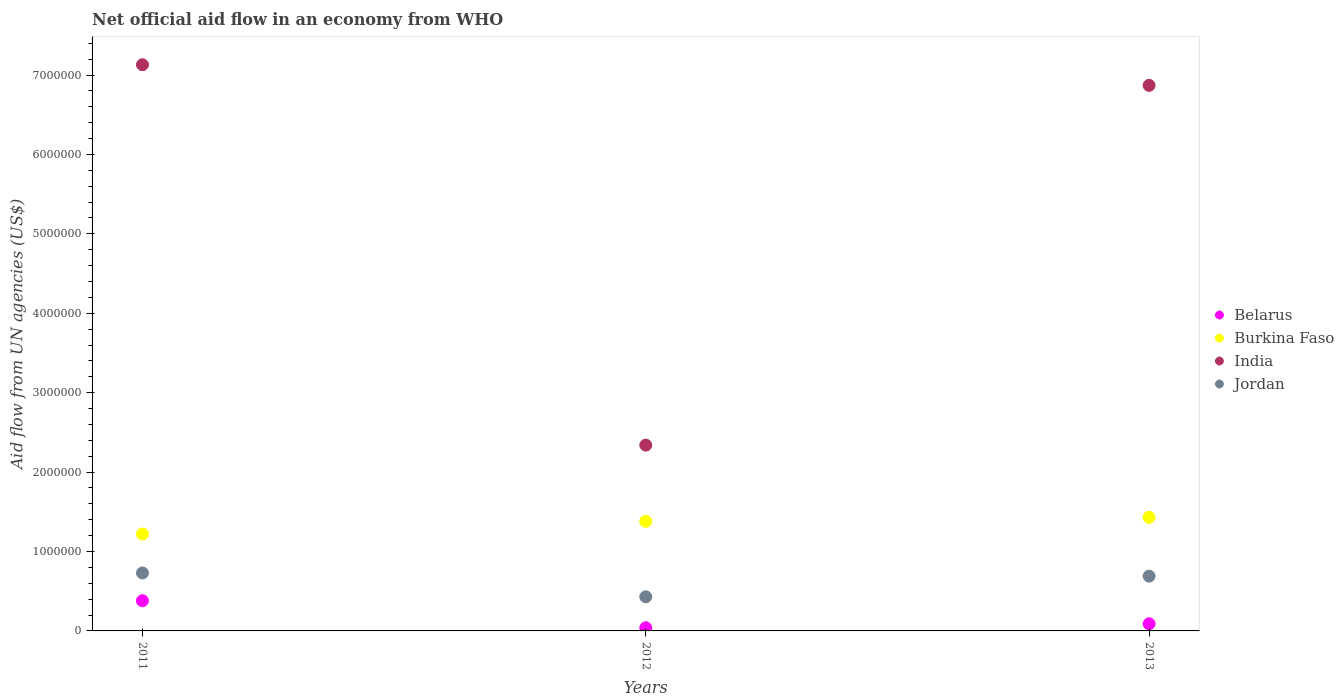What is the net official aid flow in Jordan in 2013?
Offer a terse response. 6.90e+05. Across all years, what is the maximum net official aid flow in Jordan?
Your response must be concise. 7.30e+05. What is the total net official aid flow in Belarus in the graph?
Your answer should be very brief. 5.10e+05. What is the difference between the net official aid flow in Jordan in 2011 and that in 2013?
Offer a very short reply. 4.00e+04. What is the difference between the net official aid flow in Jordan in 2011 and the net official aid flow in Belarus in 2013?
Keep it short and to the point. 6.40e+05. What is the average net official aid flow in India per year?
Offer a terse response. 5.45e+06. In the year 2011, what is the difference between the net official aid flow in Jordan and net official aid flow in Burkina Faso?
Offer a very short reply. -4.90e+05. In how many years, is the net official aid flow in Jordan greater than 200000 US$?
Make the answer very short. 3. What is the ratio of the net official aid flow in India in 2011 to that in 2012?
Your answer should be compact. 3.05. What is the difference between the highest and the lowest net official aid flow in Belarus?
Keep it short and to the point. 3.40e+05. Is it the case that in every year, the sum of the net official aid flow in Jordan and net official aid flow in Burkina Faso  is greater than the sum of net official aid flow in Belarus and net official aid flow in India?
Offer a very short reply. No. Is it the case that in every year, the sum of the net official aid flow in Belarus and net official aid flow in Jordan  is greater than the net official aid flow in Burkina Faso?
Keep it short and to the point. No. Does the net official aid flow in India monotonically increase over the years?
Offer a terse response. No. Is the net official aid flow in India strictly greater than the net official aid flow in Belarus over the years?
Provide a short and direct response. Yes. How many years are there in the graph?
Offer a terse response. 3. What is the difference between two consecutive major ticks on the Y-axis?
Give a very brief answer. 1.00e+06. Are the values on the major ticks of Y-axis written in scientific E-notation?
Make the answer very short. No. What is the title of the graph?
Offer a terse response. Net official aid flow in an economy from WHO. What is the label or title of the X-axis?
Provide a short and direct response. Years. What is the label or title of the Y-axis?
Your response must be concise. Aid flow from UN agencies (US$). What is the Aid flow from UN agencies (US$) of Belarus in 2011?
Your answer should be compact. 3.80e+05. What is the Aid flow from UN agencies (US$) in Burkina Faso in 2011?
Offer a very short reply. 1.22e+06. What is the Aid flow from UN agencies (US$) in India in 2011?
Provide a succinct answer. 7.13e+06. What is the Aid flow from UN agencies (US$) in Jordan in 2011?
Offer a very short reply. 7.30e+05. What is the Aid flow from UN agencies (US$) in Burkina Faso in 2012?
Ensure brevity in your answer.  1.38e+06. What is the Aid flow from UN agencies (US$) in India in 2012?
Your answer should be compact. 2.34e+06. What is the Aid flow from UN agencies (US$) in Belarus in 2013?
Offer a very short reply. 9.00e+04. What is the Aid flow from UN agencies (US$) in Burkina Faso in 2013?
Make the answer very short. 1.43e+06. What is the Aid flow from UN agencies (US$) of India in 2013?
Offer a terse response. 6.87e+06. What is the Aid flow from UN agencies (US$) of Jordan in 2013?
Your answer should be compact. 6.90e+05. Across all years, what is the maximum Aid flow from UN agencies (US$) of Burkina Faso?
Your answer should be very brief. 1.43e+06. Across all years, what is the maximum Aid flow from UN agencies (US$) in India?
Your answer should be compact. 7.13e+06. Across all years, what is the maximum Aid flow from UN agencies (US$) of Jordan?
Your answer should be very brief. 7.30e+05. Across all years, what is the minimum Aid flow from UN agencies (US$) of Burkina Faso?
Your answer should be very brief. 1.22e+06. Across all years, what is the minimum Aid flow from UN agencies (US$) in India?
Your response must be concise. 2.34e+06. Across all years, what is the minimum Aid flow from UN agencies (US$) in Jordan?
Provide a succinct answer. 4.30e+05. What is the total Aid flow from UN agencies (US$) of Belarus in the graph?
Provide a succinct answer. 5.10e+05. What is the total Aid flow from UN agencies (US$) of Burkina Faso in the graph?
Offer a terse response. 4.03e+06. What is the total Aid flow from UN agencies (US$) of India in the graph?
Provide a short and direct response. 1.63e+07. What is the total Aid flow from UN agencies (US$) of Jordan in the graph?
Offer a very short reply. 1.85e+06. What is the difference between the Aid flow from UN agencies (US$) in Belarus in 2011 and that in 2012?
Offer a very short reply. 3.40e+05. What is the difference between the Aid flow from UN agencies (US$) in Burkina Faso in 2011 and that in 2012?
Make the answer very short. -1.60e+05. What is the difference between the Aid flow from UN agencies (US$) of India in 2011 and that in 2012?
Make the answer very short. 4.79e+06. What is the difference between the Aid flow from UN agencies (US$) of Jordan in 2011 and that in 2012?
Keep it short and to the point. 3.00e+05. What is the difference between the Aid flow from UN agencies (US$) in Belarus in 2011 and that in 2013?
Ensure brevity in your answer.  2.90e+05. What is the difference between the Aid flow from UN agencies (US$) of Burkina Faso in 2011 and that in 2013?
Ensure brevity in your answer.  -2.10e+05. What is the difference between the Aid flow from UN agencies (US$) in India in 2011 and that in 2013?
Give a very brief answer. 2.60e+05. What is the difference between the Aid flow from UN agencies (US$) of Jordan in 2011 and that in 2013?
Ensure brevity in your answer.  4.00e+04. What is the difference between the Aid flow from UN agencies (US$) in Belarus in 2012 and that in 2013?
Offer a very short reply. -5.00e+04. What is the difference between the Aid flow from UN agencies (US$) of Burkina Faso in 2012 and that in 2013?
Provide a succinct answer. -5.00e+04. What is the difference between the Aid flow from UN agencies (US$) in India in 2012 and that in 2013?
Offer a terse response. -4.53e+06. What is the difference between the Aid flow from UN agencies (US$) in Jordan in 2012 and that in 2013?
Provide a succinct answer. -2.60e+05. What is the difference between the Aid flow from UN agencies (US$) in Belarus in 2011 and the Aid flow from UN agencies (US$) in India in 2012?
Give a very brief answer. -1.96e+06. What is the difference between the Aid flow from UN agencies (US$) of Burkina Faso in 2011 and the Aid flow from UN agencies (US$) of India in 2012?
Keep it short and to the point. -1.12e+06. What is the difference between the Aid flow from UN agencies (US$) of Burkina Faso in 2011 and the Aid flow from UN agencies (US$) of Jordan in 2012?
Provide a succinct answer. 7.90e+05. What is the difference between the Aid flow from UN agencies (US$) in India in 2011 and the Aid flow from UN agencies (US$) in Jordan in 2012?
Your answer should be compact. 6.70e+06. What is the difference between the Aid flow from UN agencies (US$) of Belarus in 2011 and the Aid flow from UN agencies (US$) of Burkina Faso in 2013?
Keep it short and to the point. -1.05e+06. What is the difference between the Aid flow from UN agencies (US$) of Belarus in 2011 and the Aid flow from UN agencies (US$) of India in 2013?
Your answer should be compact. -6.49e+06. What is the difference between the Aid flow from UN agencies (US$) in Belarus in 2011 and the Aid flow from UN agencies (US$) in Jordan in 2013?
Offer a terse response. -3.10e+05. What is the difference between the Aid flow from UN agencies (US$) of Burkina Faso in 2011 and the Aid flow from UN agencies (US$) of India in 2013?
Give a very brief answer. -5.65e+06. What is the difference between the Aid flow from UN agencies (US$) of Burkina Faso in 2011 and the Aid flow from UN agencies (US$) of Jordan in 2013?
Keep it short and to the point. 5.30e+05. What is the difference between the Aid flow from UN agencies (US$) in India in 2011 and the Aid flow from UN agencies (US$) in Jordan in 2013?
Provide a succinct answer. 6.44e+06. What is the difference between the Aid flow from UN agencies (US$) of Belarus in 2012 and the Aid flow from UN agencies (US$) of Burkina Faso in 2013?
Provide a short and direct response. -1.39e+06. What is the difference between the Aid flow from UN agencies (US$) of Belarus in 2012 and the Aid flow from UN agencies (US$) of India in 2013?
Make the answer very short. -6.83e+06. What is the difference between the Aid flow from UN agencies (US$) of Belarus in 2012 and the Aid flow from UN agencies (US$) of Jordan in 2013?
Offer a very short reply. -6.50e+05. What is the difference between the Aid flow from UN agencies (US$) in Burkina Faso in 2012 and the Aid flow from UN agencies (US$) in India in 2013?
Keep it short and to the point. -5.49e+06. What is the difference between the Aid flow from UN agencies (US$) in Burkina Faso in 2012 and the Aid flow from UN agencies (US$) in Jordan in 2013?
Offer a very short reply. 6.90e+05. What is the difference between the Aid flow from UN agencies (US$) in India in 2012 and the Aid flow from UN agencies (US$) in Jordan in 2013?
Provide a succinct answer. 1.65e+06. What is the average Aid flow from UN agencies (US$) in Belarus per year?
Your answer should be compact. 1.70e+05. What is the average Aid flow from UN agencies (US$) of Burkina Faso per year?
Your answer should be compact. 1.34e+06. What is the average Aid flow from UN agencies (US$) in India per year?
Provide a short and direct response. 5.45e+06. What is the average Aid flow from UN agencies (US$) in Jordan per year?
Ensure brevity in your answer.  6.17e+05. In the year 2011, what is the difference between the Aid flow from UN agencies (US$) in Belarus and Aid flow from UN agencies (US$) in Burkina Faso?
Your answer should be compact. -8.40e+05. In the year 2011, what is the difference between the Aid flow from UN agencies (US$) in Belarus and Aid flow from UN agencies (US$) in India?
Your response must be concise. -6.75e+06. In the year 2011, what is the difference between the Aid flow from UN agencies (US$) in Belarus and Aid flow from UN agencies (US$) in Jordan?
Your answer should be very brief. -3.50e+05. In the year 2011, what is the difference between the Aid flow from UN agencies (US$) of Burkina Faso and Aid flow from UN agencies (US$) of India?
Keep it short and to the point. -5.91e+06. In the year 2011, what is the difference between the Aid flow from UN agencies (US$) of Burkina Faso and Aid flow from UN agencies (US$) of Jordan?
Keep it short and to the point. 4.90e+05. In the year 2011, what is the difference between the Aid flow from UN agencies (US$) of India and Aid flow from UN agencies (US$) of Jordan?
Provide a short and direct response. 6.40e+06. In the year 2012, what is the difference between the Aid flow from UN agencies (US$) in Belarus and Aid flow from UN agencies (US$) in Burkina Faso?
Make the answer very short. -1.34e+06. In the year 2012, what is the difference between the Aid flow from UN agencies (US$) of Belarus and Aid flow from UN agencies (US$) of India?
Provide a short and direct response. -2.30e+06. In the year 2012, what is the difference between the Aid flow from UN agencies (US$) in Belarus and Aid flow from UN agencies (US$) in Jordan?
Provide a short and direct response. -3.90e+05. In the year 2012, what is the difference between the Aid flow from UN agencies (US$) of Burkina Faso and Aid flow from UN agencies (US$) of India?
Ensure brevity in your answer.  -9.60e+05. In the year 2012, what is the difference between the Aid flow from UN agencies (US$) in Burkina Faso and Aid flow from UN agencies (US$) in Jordan?
Keep it short and to the point. 9.50e+05. In the year 2012, what is the difference between the Aid flow from UN agencies (US$) of India and Aid flow from UN agencies (US$) of Jordan?
Your answer should be very brief. 1.91e+06. In the year 2013, what is the difference between the Aid flow from UN agencies (US$) in Belarus and Aid flow from UN agencies (US$) in Burkina Faso?
Offer a very short reply. -1.34e+06. In the year 2013, what is the difference between the Aid flow from UN agencies (US$) in Belarus and Aid flow from UN agencies (US$) in India?
Your response must be concise. -6.78e+06. In the year 2013, what is the difference between the Aid flow from UN agencies (US$) in Belarus and Aid flow from UN agencies (US$) in Jordan?
Your answer should be very brief. -6.00e+05. In the year 2013, what is the difference between the Aid flow from UN agencies (US$) of Burkina Faso and Aid flow from UN agencies (US$) of India?
Provide a succinct answer. -5.44e+06. In the year 2013, what is the difference between the Aid flow from UN agencies (US$) in Burkina Faso and Aid flow from UN agencies (US$) in Jordan?
Offer a terse response. 7.40e+05. In the year 2013, what is the difference between the Aid flow from UN agencies (US$) of India and Aid flow from UN agencies (US$) of Jordan?
Your answer should be compact. 6.18e+06. What is the ratio of the Aid flow from UN agencies (US$) in Belarus in 2011 to that in 2012?
Give a very brief answer. 9.5. What is the ratio of the Aid flow from UN agencies (US$) in Burkina Faso in 2011 to that in 2012?
Keep it short and to the point. 0.88. What is the ratio of the Aid flow from UN agencies (US$) in India in 2011 to that in 2012?
Your answer should be compact. 3.05. What is the ratio of the Aid flow from UN agencies (US$) in Jordan in 2011 to that in 2012?
Your answer should be very brief. 1.7. What is the ratio of the Aid flow from UN agencies (US$) of Belarus in 2011 to that in 2013?
Offer a terse response. 4.22. What is the ratio of the Aid flow from UN agencies (US$) in Burkina Faso in 2011 to that in 2013?
Your answer should be compact. 0.85. What is the ratio of the Aid flow from UN agencies (US$) in India in 2011 to that in 2013?
Provide a succinct answer. 1.04. What is the ratio of the Aid flow from UN agencies (US$) in Jordan in 2011 to that in 2013?
Keep it short and to the point. 1.06. What is the ratio of the Aid flow from UN agencies (US$) of Belarus in 2012 to that in 2013?
Give a very brief answer. 0.44. What is the ratio of the Aid flow from UN agencies (US$) of India in 2012 to that in 2013?
Offer a terse response. 0.34. What is the ratio of the Aid flow from UN agencies (US$) in Jordan in 2012 to that in 2013?
Make the answer very short. 0.62. What is the difference between the highest and the second highest Aid flow from UN agencies (US$) in Belarus?
Provide a short and direct response. 2.90e+05. What is the difference between the highest and the second highest Aid flow from UN agencies (US$) of Burkina Faso?
Offer a very short reply. 5.00e+04. What is the difference between the highest and the second highest Aid flow from UN agencies (US$) of India?
Give a very brief answer. 2.60e+05. What is the difference between the highest and the second highest Aid flow from UN agencies (US$) in Jordan?
Offer a very short reply. 4.00e+04. What is the difference between the highest and the lowest Aid flow from UN agencies (US$) in Burkina Faso?
Make the answer very short. 2.10e+05. What is the difference between the highest and the lowest Aid flow from UN agencies (US$) in India?
Provide a succinct answer. 4.79e+06. 